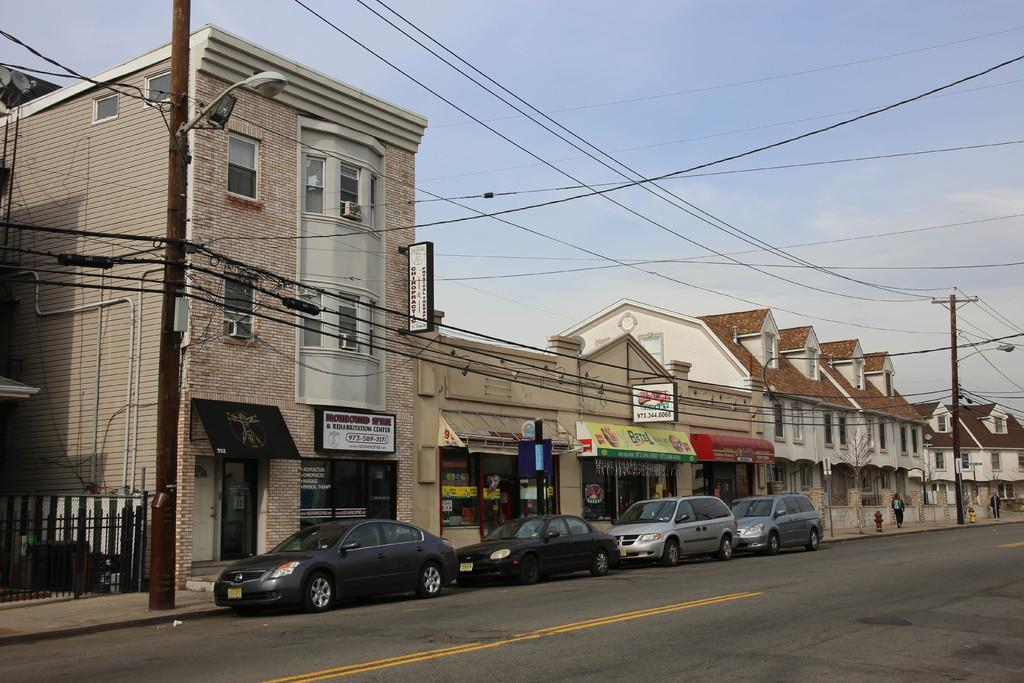How many cars are on the road in the image? There are four cars on the road in the image. What other structures can be seen in the image besides the cars? There are poles, wires, boards, a fence, buildings, and a hydrant in the image. Are there any people present in the image? Yes, there are two persons in the image. What is visible in the background of the image? The sky is visible in the background of the image. What type of request can be seen written on the boards in the image? There is no request visible on the boards in the image; they are just plain boards. 